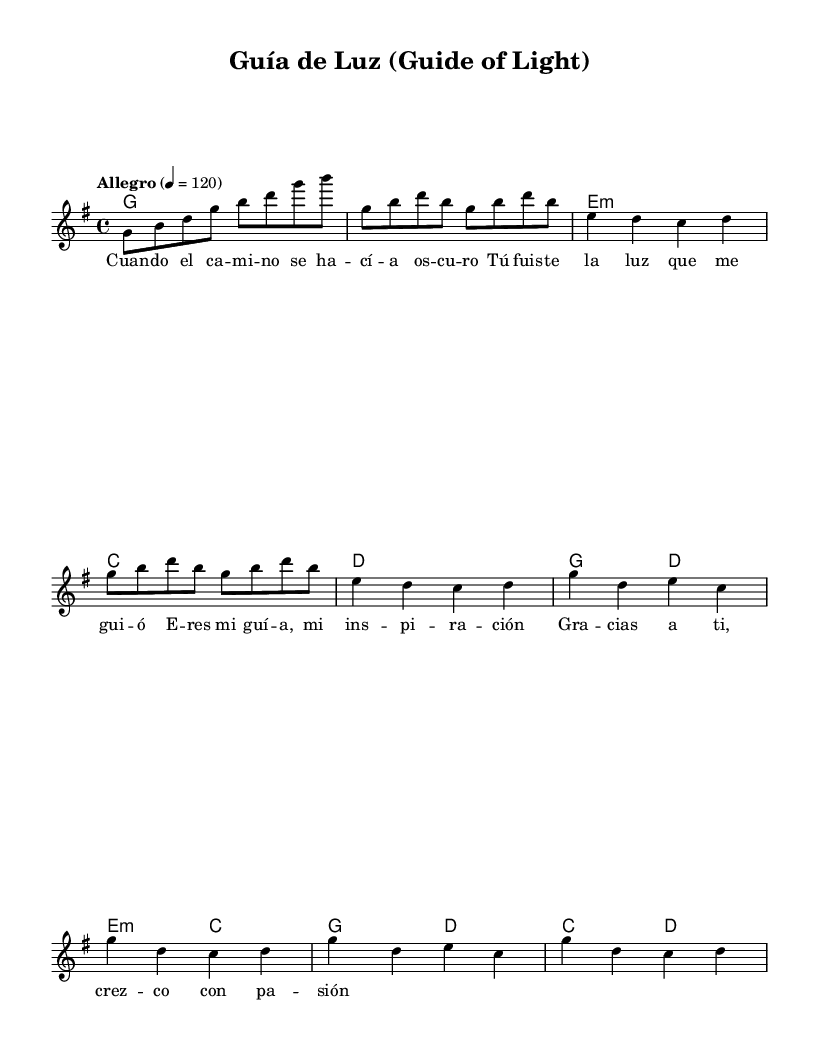What is the key signature of this music? The key signature is G major, which has one sharp (F#). This is evident at the beginning of the sheet music where the key signature clef is indicated.
Answer: G major What is the time signature of this music? The time signature is 4/4, indicated at the beginning of the sheet music. This means there are four beats per measure, and each beat is a quarter note.
Answer: 4/4 What is the tempo marking for this piece? The tempo marking is Allegro, which is indicated at the beginning along with the beats per minute (120). The word "Allegro" conveys a fast and lively pace.
Answer: Allegro How many measures are in the verse? The verse consists of four measures, as can be counted from the music notation provided. Each line indicates measures separated by vertical lines, and the verse specifically has a set number of these.
Answer: 4 What is the primary theme of the lyrics? The primary theme of the lyrics revolves around guidance and inspiration, specifically appreciating a mentor's influence. This is derived from the lyrics that express gratitude and growth attributed to the mentioned guide.
Answer: Guidance How many chords are used in the chorus section? The chorus section utilizes four chords: G, D, E minor, and C, as can be identified in the harmonic progression aligned with the lyrics of the chorus.
Answer: 4 Identify the role of the lead melody in this piece. The lead melody serves as the main vocal line and carries the principal melodic content of the song, closely tied to the lyrics. The melody is notated in the staff, and it defines the song's character and emotional expression.
Answer: Lead vocal 